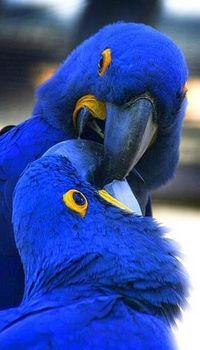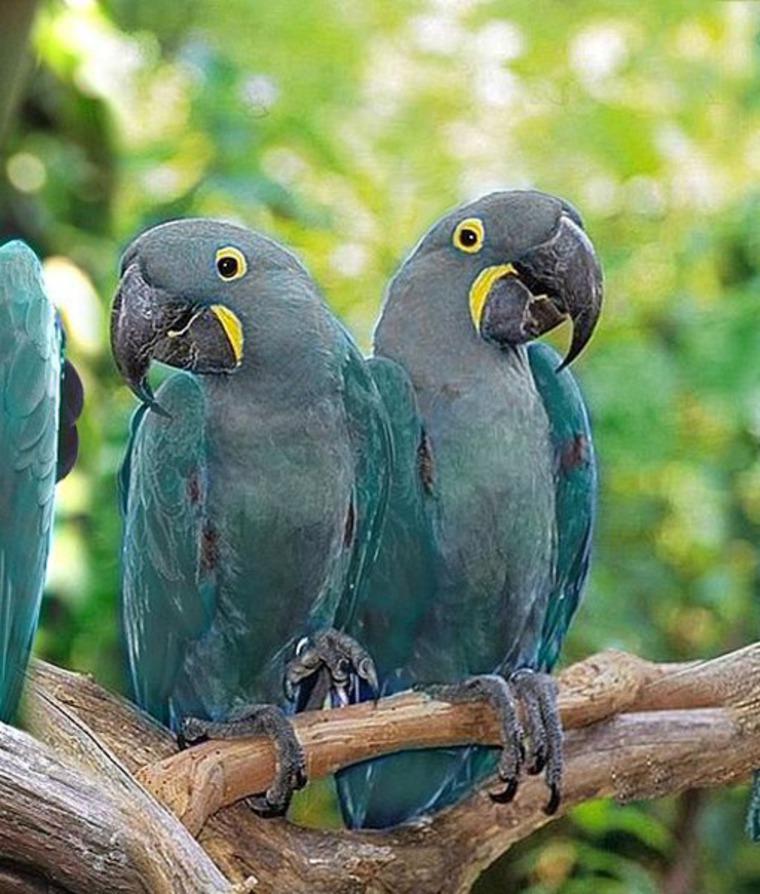The first image is the image on the left, the second image is the image on the right. Examine the images to the left and right. Is the description "Each image contains at least two blue-feathered birds, and one image shows birds perched on leafless branches." accurate? Answer yes or no. Yes. The first image is the image on the left, the second image is the image on the right. Considering the images on both sides, is "The right image contains at least two blue parrots." valid? Answer yes or no. Yes. 